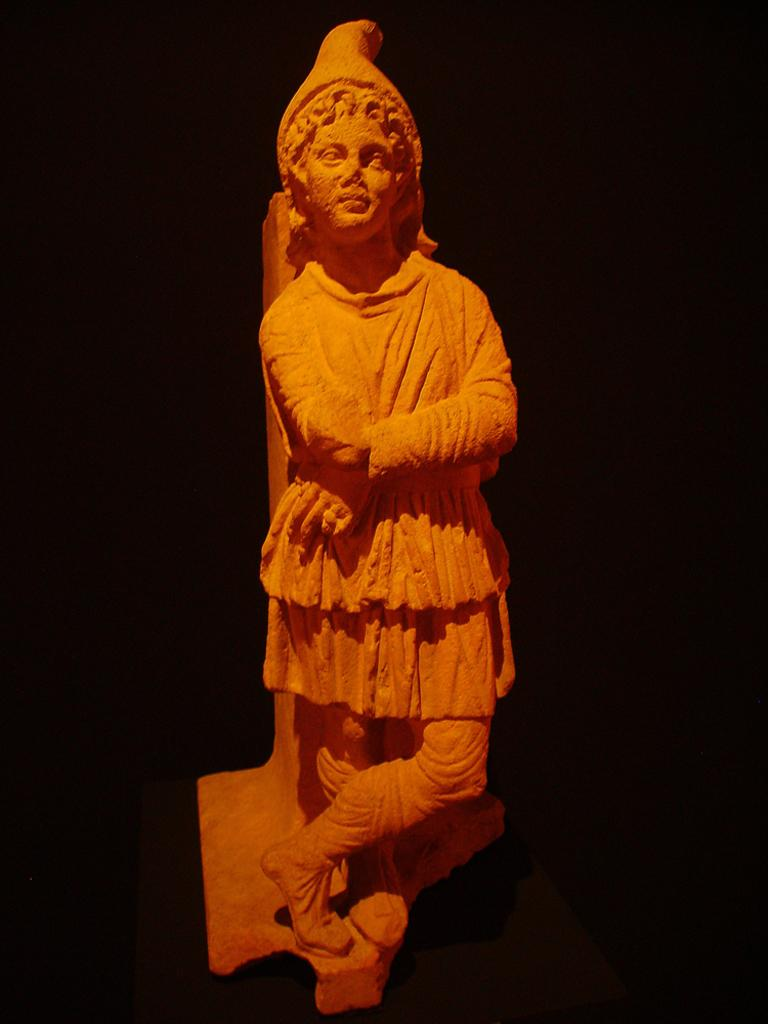What is the main subject of the image? There is a statue in the image. What is the statue of? The statue is of a person. What is the person in the statue doing? The person depicted in the statue is folding their hands. What position is the person in the statue in? The person in the statue is standing. What type of cover is on the statue in the image? There is no cover present on the statue in the image. What message of peace does the statue convey in the image? The statue does not convey a message of peace, as it is a depiction of a person folding their hands. 